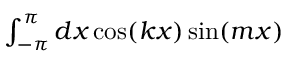Convert formula to latex. <formula><loc_0><loc_0><loc_500><loc_500>\begin{array} { r } { \int _ { - \pi } ^ { \pi } d x \cos ( k x ) \sin ( m x ) } \end{array}</formula> 